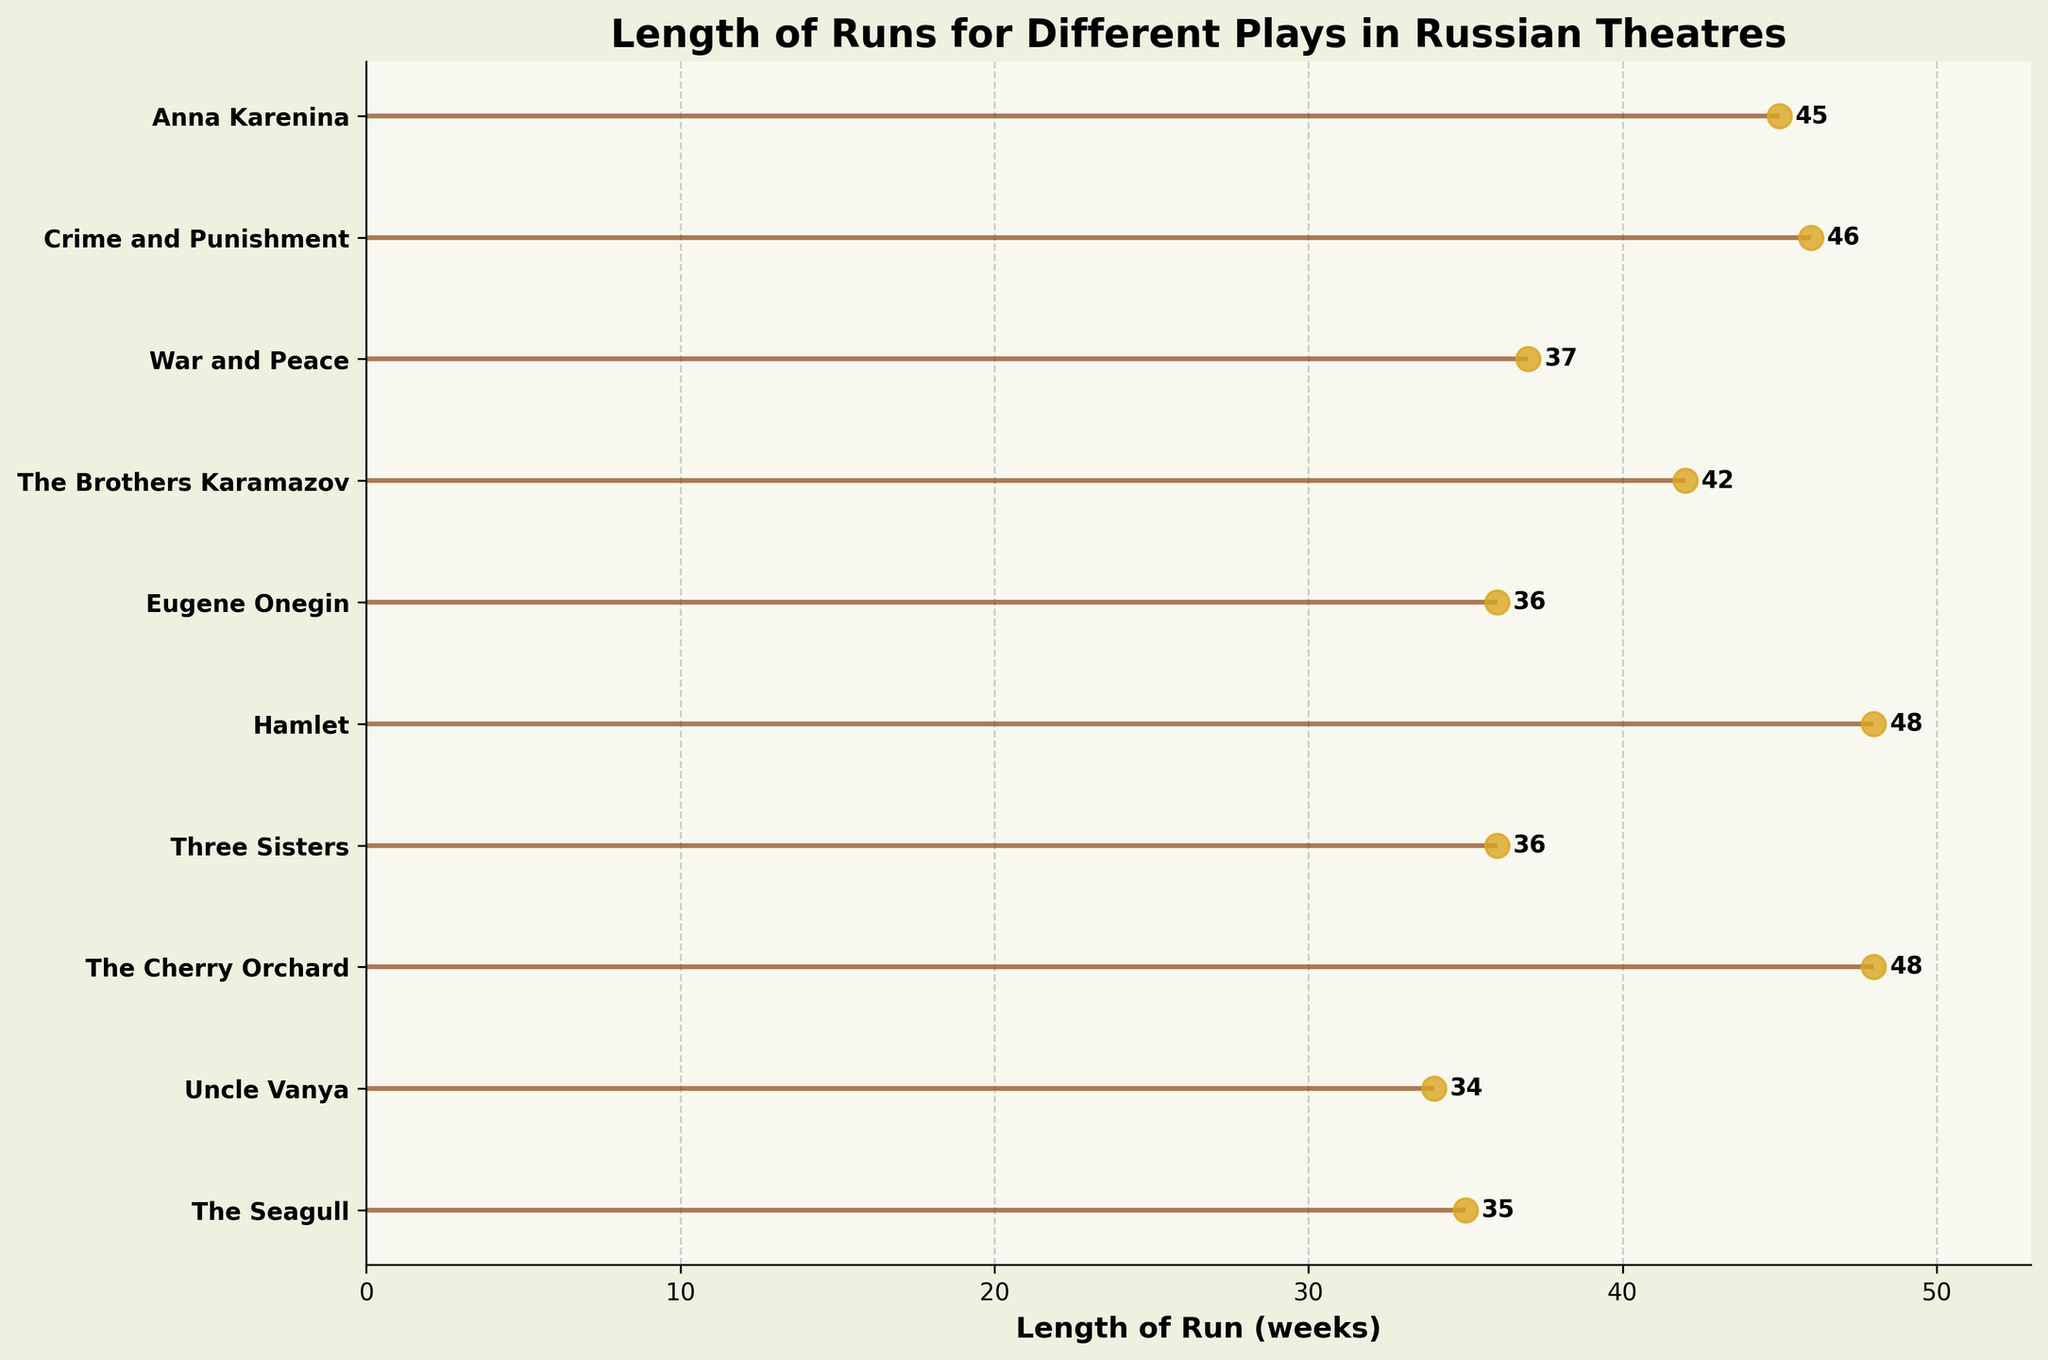Which play has the longest run time as shown in the plot? Observe the dot on the horizontal line that extends the furthest to the right. The play "The Cherry Orchard" and "Hamlet" both have dots at the same furthest point, indicating that they have the longest run time.
Answer: "The Cherry Orchard" and "Hamlet" What is the title of the plot? Read the large, bold text at the top of the figure. The title summarizes what the chart represents.
Answer: Length of Runs for Different Plays in Russian Theatres How many plays have a run time of exactly 36 weeks? Count the horizontal lines ending with a dot positioned at the 36-week mark on the x-axis. Both "Three Sisters" and "Eugene Onegin" end at 36 weeks.
Answer: 2 Which play has the shortest run time? Look for the dot closest to the origin (starting point of the x-axis). "Uncle Vanya" has the shortest run time, indicated by its dot at 34 weeks.
Answer: "Uncle Vanya" What is the average length of runs for the plays "The Brothers Karamazov" and "Anna Karenina"? Find the number of weeks for both plays ("The Brothers Karamazov" = 42 and "Anna Karenina" = 45), sum these values (42 + 45 = 87), and divide by 2 to find the average.
Answer: 43.5 Which play ran for 37 weeks? Look for the play with a dot that aligns with the 37-week mark on the x-axis. "War and Peace" has a dot at 37 weeks.
Answer: "War and Peace" What is the range (difference between the longest and shortest) of the play run times? Identify the longest run length (48 weeks) and the shortest run length (34 weeks). Subtract the shortest length from the longest (48 - 34).
Answer: 14 weeks How many plays had a run length of over 40 weeks? Count the number of horizontal lines with dots placed beyond the 40-week mark on the x-axis. There are four such plays ("The Cherry Orchard," "Hamlet," "Crime and Punishment," and "Anna Karenina").
Answer: 4 Which theatre had "Hamlet" performed? Find the play "Hamlet" on the y-axis and refer to the corresponding theatre label mentioned alongside it. "Hamlet" was performed at the Theatre of Nations.
Answer: Theatre of Nations How many different plays are shown in the plot? Count the number of distinct names listed on the y-axis, where each play is individually labeled. There are ten different plays listed.
Answer: 10 